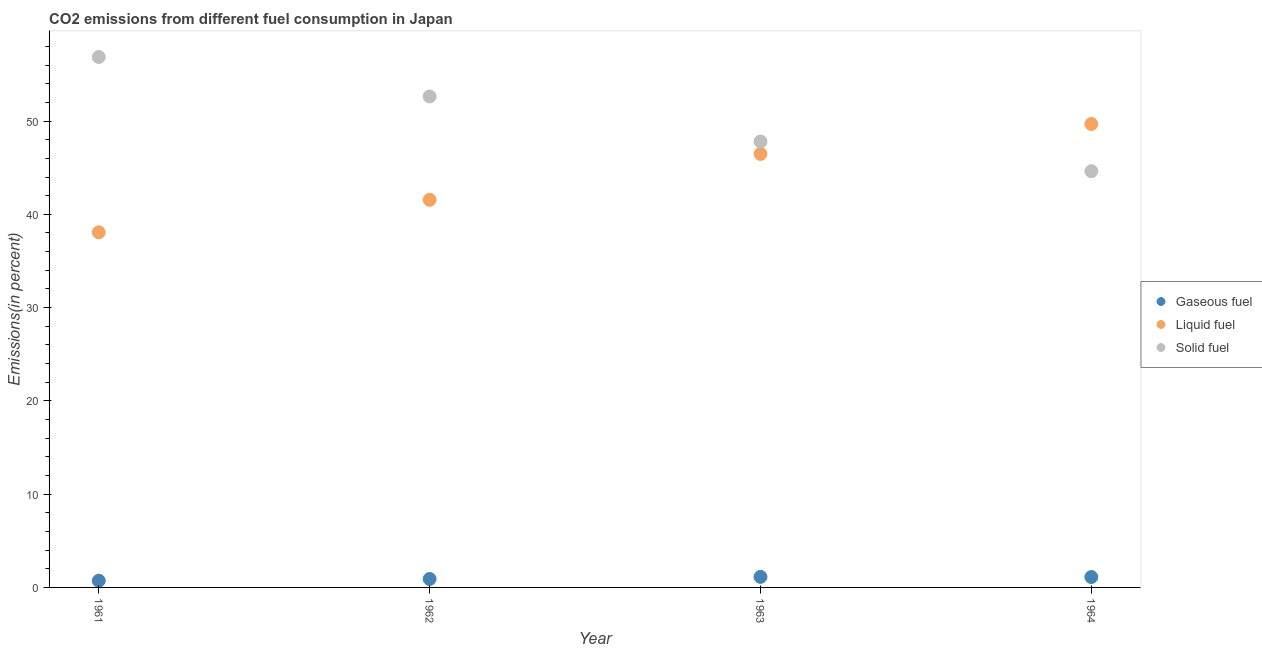How many different coloured dotlines are there?
Provide a short and direct response. 3. What is the percentage of liquid fuel emission in 1962?
Ensure brevity in your answer.  41.56. Across all years, what is the maximum percentage of liquid fuel emission?
Make the answer very short. 49.69. Across all years, what is the minimum percentage of liquid fuel emission?
Provide a succinct answer. 38.07. In which year was the percentage of gaseous fuel emission maximum?
Your response must be concise. 1963. What is the total percentage of liquid fuel emission in the graph?
Offer a terse response. 175.79. What is the difference between the percentage of solid fuel emission in 1962 and that in 1963?
Keep it short and to the point. 4.83. What is the difference between the percentage of gaseous fuel emission in 1963 and the percentage of liquid fuel emission in 1962?
Provide a succinct answer. -40.43. What is the average percentage of solid fuel emission per year?
Ensure brevity in your answer.  50.48. In the year 1962, what is the difference between the percentage of liquid fuel emission and percentage of solid fuel emission?
Give a very brief answer. -11.08. What is the ratio of the percentage of liquid fuel emission in 1962 to that in 1964?
Your answer should be compact. 0.84. Is the percentage of solid fuel emission in 1962 less than that in 1963?
Ensure brevity in your answer.  No. What is the difference between the highest and the second highest percentage of liquid fuel emission?
Make the answer very short. 3.21. What is the difference between the highest and the lowest percentage of gaseous fuel emission?
Give a very brief answer. 0.41. Does the percentage of liquid fuel emission monotonically increase over the years?
Ensure brevity in your answer.  Yes. Is the percentage of gaseous fuel emission strictly greater than the percentage of solid fuel emission over the years?
Offer a terse response. No. Is the percentage of solid fuel emission strictly less than the percentage of liquid fuel emission over the years?
Keep it short and to the point. No. What is the difference between two consecutive major ticks on the Y-axis?
Your answer should be very brief. 10. Does the graph contain grids?
Ensure brevity in your answer.  No. What is the title of the graph?
Make the answer very short. CO2 emissions from different fuel consumption in Japan. What is the label or title of the X-axis?
Make the answer very short. Year. What is the label or title of the Y-axis?
Give a very brief answer. Emissions(in percent). What is the Emissions(in percent) in Gaseous fuel in 1961?
Provide a short and direct response. 0.72. What is the Emissions(in percent) in Liquid fuel in 1961?
Your answer should be very brief. 38.07. What is the Emissions(in percent) in Solid fuel in 1961?
Your answer should be very brief. 56.87. What is the Emissions(in percent) in Gaseous fuel in 1962?
Give a very brief answer. 0.91. What is the Emissions(in percent) in Liquid fuel in 1962?
Offer a very short reply. 41.56. What is the Emissions(in percent) of Solid fuel in 1962?
Provide a short and direct response. 52.64. What is the Emissions(in percent) in Gaseous fuel in 1963?
Your response must be concise. 1.13. What is the Emissions(in percent) of Liquid fuel in 1963?
Offer a terse response. 46.47. What is the Emissions(in percent) of Solid fuel in 1963?
Offer a very short reply. 47.8. What is the Emissions(in percent) of Gaseous fuel in 1964?
Keep it short and to the point. 1.12. What is the Emissions(in percent) in Liquid fuel in 1964?
Your response must be concise. 49.69. What is the Emissions(in percent) of Solid fuel in 1964?
Your response must be concise. 44.62. Across all years, what is the maximum Emissions(in percent) of Gaseous fuel?
Provide a short and direct response. 1.13. Across all years, what is the maximum Emissions(in percent) of Liquid fuel?
Keep it short and to the point. 49.69. Across all years, what is the maximum Emissions(in percent) in Solid fuel?
Provide a short and direct response. 56.87. Across all years, what is the minimum Emissions(in percent) of Gaseous fuel?
Provide a short and direct response. 0.72. Across all years, what is the minimum Emissions(in percent) in Liquid fuel?
Provide a short and direct response. 38.07. Across all years, what is the minimum Emissions(in percent) of Solid fuel?
Ensure brevity in your answer.  44.62. What is the total Emissions(in percent) of Gaseous fuel in the graph?
Ensure brevity in your answer.  3.88. What is the total Emissions(in percent) in Liquid fuel in the graph?
Give a very brief answer. 175.79. What is the total Emissions(in percent) in Solid fuel in the graph?
Your response must be concise. 201.93. What is the difference between the Emissions(in percent) of Gaseous fuel in 1961 and that in 1962?
Ensure brevity in your answer.  -0.19. What is the difference between the Emissions(in percent) of Liquid fuel in 1961 and that in 1962?
Your response must be concise. -3.49. What is the difference between the Emissions(in percent) in Solid fuel in 1961 and that in 1962?
Make the answer very short. 4.23. What is the difference between the Emissions(in percent) of Gaseous fuel in 1961 and that in 1963?
Make the answer very short. -0.41. What is the difference between the Emissions(in percent) of Liquid fuel in 1961 and that in 1963?
Make the answer very short. -8.4. What is the difference between the Emissions(in percent) in Solid fuel in 1961 and that in 1963?
Offer a terse response. 9.06. What is the difference between the Emissions(in percent) in Gaseous fuel in 1961 and that in 1964?
Give a very brief answer. -0.39. What is the difference between the Emissions(in percent) in Liquid fuel in 1961 and that in 1964?
Make the answer very short. -11.61. What is the difference between the Emissions(in percent) of Solid fuel in 1961 and that in 1964?
Offer a very short reply. 12.24. What is the difference between the Emissions(in percent) in Gaseous fuel in 1962 and that in 1963?
Make the answer very short. -0.22. What is the difference between the Emissions(in percent) in Liquid fuel in 1962 and that in 1963?
Make the answer very short. -4.92. What is the difference between the Emissions(in percent) in Solid fuel in 1962 and that in 1963?
Provide a short and direct response. 4.83. What is the difference between the Emissions(in percent) in Gaseous fuel in 1962 and that in 1964?
Your response must be concise. -0.21. What is the difference between the Emissions(in percent) of Liquid fuel in 1962 and that in 1964?
Make the answer very short. -8.13. What is the difference between the Emissions(in percent) in Solid fuel in 1962 and that in 1964?
Provide a short and direct response. 8.01. What is the difference between the Emissions(in percent) in Gaseous fuel in 1963 and that in 1964?
Your response must be concise. 0.01. What is the difference between the Emissions(in percent) of Liquid fuel in 1963 and that in 1964?
Provide a succinct answer. -3.21. What is the difference between the Emissions(in percent) of Solid fuel in 1963 and that in 1964?
Ensure brevity in your answer.  3.18. What is the difference between the Emissions(in percent) of Gaseous fuel in 1961 and the Emissions(in percent) of Liquid fuel in 1962?
Provide a short and direct response. -40.84. What is the difference between the Emissions(in percent) of Gaseous fuel in 1961 and the Emissions(in percent) of Solid fuel in 1962?
Ensure brevity in your answer.  -51.91. What is the difference between the Emissions(in percent) in Liquid fuel in 1961 and the Emissions(in percent) in Solid fuel in 1962?
Offer a terse response. -14.56. What is the difference between the Emissions(in percent) in Gaseous fuel in 1961 and the Emissions(in percent) in Liquid fuel in 1963?
Your answer should be very brief. -45.75. What is the difference between the Emissions(in percent) of Gaseous fuel in 1961 and the Emissions(in percent) of Solid fuel in 1963?
Offer a terse response. -47.08. What is the difference between the Emissions(in percent) in Liquid fuel in 1961 and the Emissions(in percent) in Solid fuel in 1963?
Ensure brevity in your answer.  -9.73. What is the difference between the Emissions(in percent) in Gaseous fuel in 1961 and the Emissions(in percent) in Liquid fuel in 1964?
Ensure brevity in your answer.  -48.96. What is the difference between the Emissions(in percent) of Gaseous fuel in 1961 and the Emissions(in percent) of Solid fuel in 1964?
Keep it short and to the point. -43.9. What is the difference between the Emissions(in percent) in Liquid fuel in 1961 and the Emissions(in percent) in Solid fuel in 1964?
Offer a very short reply. -6.55. What is the difference between the Emissions(in percent) of Gaseous fuel in 1962 and the Emissions(in percent) of Liquid fuel in 1963?
Your answer should be compact. -45.57. What is the difference between the Emissions(in percent) of Gaseous fuel in 1962 and the Emissions(in percent) of Solid fuel in 1963?
Keep it short and to the point. -46.9. What is the difference between the Emissions(in percent) of Liquid fuel in 1962 and the Emissions(in percent) of Solid fuel in 1963?
Keep it short and to the point. -6.24. What is the difference between the Emissions(in percent) of Gaseous fuel in 1962 and the Emissions(in percent) of Liquid fuel in 1964?
Your answer should be compact. -48.78. What is the difference between the Emissions(in percent) of Gaseous fuel in 1962 and the Emissions(in percent) of Solid fuel in 1964?
Your response must be concise. -43.72. What is the difference between the Emissions(in percent) in Liquid fuel in 1962 and the Emissions(in percent) in Solid fuel in 1964?
Your answer should be very brief. -3.06. What is the difference between the Emissions(in percent) of Gaseous fuel in 1963 and the Emissions(in percent) of Liquid fuel in 1964?
Your answer should be very brief. -48.56. What is the difference between the Emissions(in percent) of Gaseous fuel in 1963 and the Emissions(in percent) of Solid fuel in 1964?
Your response must be concise. -43.49. What is the difference between the Emissions(in percent) of Liquid fuel in 1963 and the Emissions(in percent) of Solid fuel in 1964?
Your answer should be very brief. 1.85. What is the average Emissions(in percent) in Gaseous fuel per year?
Keep it short and to the point. 0.97. What is the average Emissions(in percent) of Liquid fuel per year?
Provide a short and direct response. 43.95. What is the average Emissions(in percent) of Solid fuel per year?
Provide a succinct answer. 50.48. In the year 1961, what is the difference between the Emissions(in percent) in Gaseous fuel and Emissions(in percent) in Liquid fuel?
Your answer should be very brief. -37.35. In the year 1961, what is the difference between the Emissions(in percent) of Gaseous fuel and Emissions(in percent) of Solid fuel?
Make the answer very short. -56.14. In the year 1961, what is the difference between the Emissions(in percent) of Liquid fuel and Emissions(in percent) of Solid fuel?
Your answer should be very brief. -18.79. In the year 1962, what is the difference between the Emissions(in percent) of Gaseous fuel and Emissions(in percent) of Liquid fuel?
Your response must be concise. -40.65. In the year 1962, what is the difference between the Emissions(in percent) of Gaseous fuel and Emissions(in percent) of Solid fuel?
Ensure brevity in your answer.  -51.73. In the year 1962, what is the difference between the Emissions(in percent) of Liquid fuel and Emissions(in percent) of Solid fuel?
Provide a short and direct response. -11.08. In the year 1963, what is the difference between the Emissions(in percent) of Gaseous fuel and Emissions(in percent) of Liquid fuel?
Your answer should be very brief. -45.34. In the year 1963, what is the difference between the Emissions(in percent) of Gaseous fuel and Emissions(in percent) of Solid fuel?
Offer a terse response. -46.67. In the year 1963, what is the difference between the Emissions(in percent) in Liquid fuel and Emissions(in percent) in Solid fuel?
Your response must be concise. -1.33. In the year 1964, what is the difference between the Emissions(in percent) in Gaseous fuel and Emissions(in percent) in Liquid fuel?
Make the answer very short. -48.57. In the year 1964, what is the difference between the Emissions(in percent) of Gaseous fuel and Emissions(in percent) of Solid fuel?
Make the answer very short. -43.51. In the year 1964, what is the difference between the Emissions(in percent) of Liquid fuel and Emissions(in percent) of Solid fuel?
Make the answer very short. 5.06. What is the ratio of the Emissions(in percent) of Gaseous fuel in 1961 to that in 1962?
Keep it short and to the point. 0.8. What is the ratio of the Emissions(in percent) in Liquid fuel in 1961 to that in 1962?
Your answer should be very brief. 0.92. What is the ratio of the Emissions(in percent) of Solid fuel in 1961 to that in 1962?
Make the answer very short. 1.08. What is the ratio of the Emissions(in percent) in Gaseous fuel in 1961 to that in 1963?
Your response must be concise. 0.64. What is the ratio of the Emissions(in percent) in Liquid fuel in 1961 to that in 1963?
Provide a succinct answer. 0.82. What is the ratio of the Emissions(in percent) in Solid fuel in 1961 to that in 1963?
Offer a terse response. 1.19. What is the ratio of the Emissions(in percent) of Gaseous fuel in 1961 to that in 1964?
Provide a short and direct response. 0.65. What is the ratio of the Emissions(in percent) in Liquid fuel in 1961 to that in 1964?
Provide a succinct answer. 0.77. What is the ratio of the Emissions(in percent) in Solid fuel in 1961 to that in 1964?
Offer a very short reply. 1.27. What is the ratio of the Emissions(in percent) of Gaseous fuel in 1962 to that in 1963?
Offer a very short reply. 0.8. What is the ratio of the Emissions(in percent) of Liquid fuel in 1962 to that in 1963?
Make the answer very short. 0.89. What is the ratio of the Emissions(in percent) in Solid fuel in 1962 to that in 1963?
Offer a very short reply. 1.1. What is the ratio of the Emissions(in percent) of Gaseous fuel in 1962 to that in 1964?
Your response must be concise. 0.81. What is the ratio of the Emissions(in percent) in Liquid fuel in 1962 to that in 1964?
Offer a very short reply. 0.84. What is the ratio of the Emissions(in percent) of Solid fuel in 1962 to that in 1964?
Provide a succinct answer. 1.18. What is the ratio of the Emissions(in percent) of Gaseous fuel in 1963 to that in 1964?
Offer a very short reply. 1.01. What is the ratio of the Emissions(in percent) of Liquid fuel in 1963 to that in 1964?
Keep it short and to the point. 0.94. What is the ratio of the Emissions(in percent) of Solid fuel in 1963 to that in 1964?
Your answer should be compact. 1.07. What is the difference between the highest and the second highest Emissions(in percent) of Gaseous fuel?
Offer a very short reply. 0.01. What is the difference between the highest and the second highest Emissions(in percent) in Liquid fuel?
Make the answer very short. 3.21. What is the difference between the highest and the second highest Emissions(in percent) of Solid fuel?
Offer a terse response. 4.23. What is the difference between the highest and the lowest Emissions(in percent) of Gaseous fuel?
Your answer should be very brief. 0.41. What is the difference between the highest and the lowest Emissions(in percent) in Liquid fuel?
Make the answer very short. 11.61. What is the difference between the highest and the lowest Emissions(in percent) in Solid fuel?
Your answer should be very brief. 12.24. 